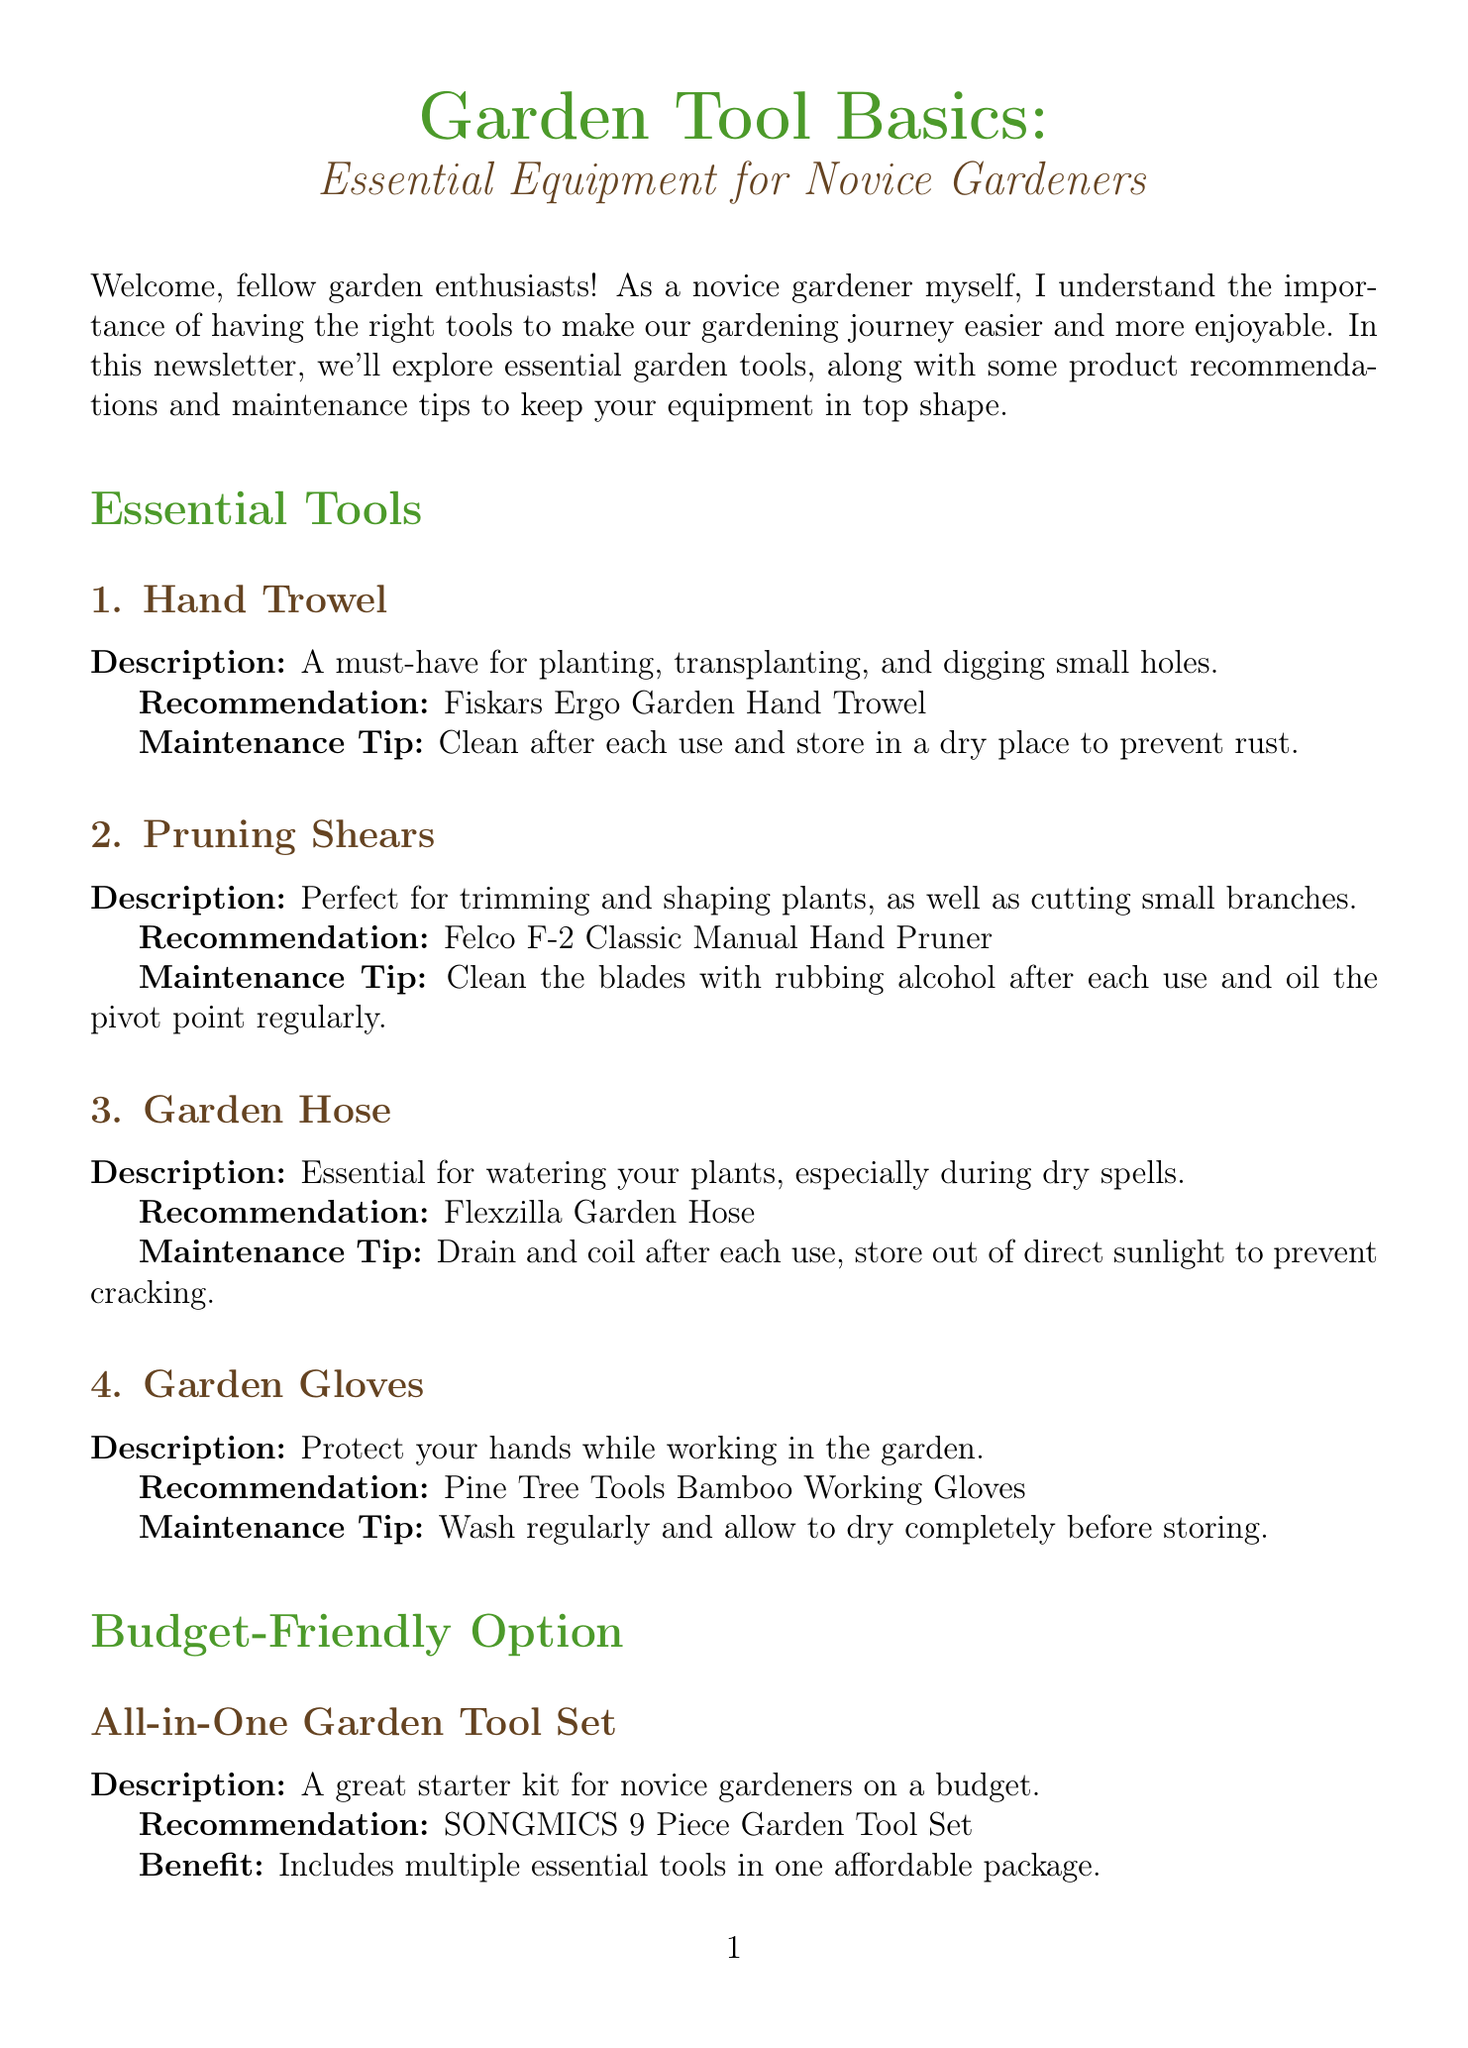What is the newsletter title? The title of the newsletter is explicitly stated at the beginning of the document.
Answer: Garden Tool Basics: Essential Equipment for Novice Gardeners What tool is recommended for planting and digging small holes? The document lists the essential tools and provides recommendations for each; the hand trowel is mentioned for this purpose.
Answer: Fiskars Ergo Garden Hand Trowel What is one maintenance tip for pruning shears? The maintenance tips for each tool are provided in the document; for pruning shears, one of the tips is given.
Answer: Clean the blades with rubbing alcohol after each use Which community garden is featured in the spotlight? The community spotlight section includes the name of a specific community garden.
Answer: Green Thumb Community Garden What is a seasonal tip mentioned in the newsletter? The document offers seasonal advice related to inspecting and cleaning tools as spring approaches.
Answer: Inspect and clean your garden tools How many pieces are in the budget-friendly garden tool set? The budget-friendly option lists the number of pieces in the set available for novice gardeners.
Answer: 9 Piece What is the benefit of the all-in-one garden tool set? The document states a specific benefit of the recommended garden tool set directly in the description.
Answer: Includes multiple essential tools in one affordable package What is the author’s advice regarding the quality of tools? The expert advice section provides a specific recommendation regarding tool quality for gardeners.
Answer: Invest in a few good-quality tools What should be done with garden gloves after use? The maintenance tips advise on proper care for garden gloves, which includes washing them.
Answer: Wash regularly and allow to dry completely before storing 